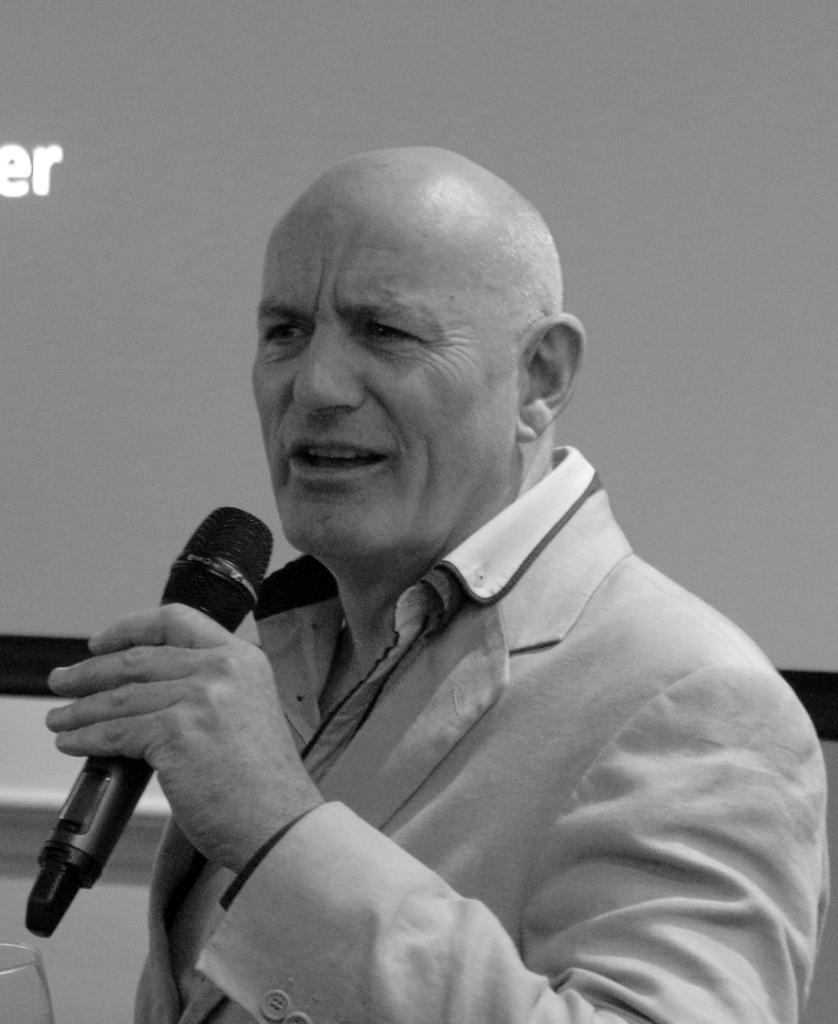What is the person in the image doing? The person is standing and holding a microphone. What might the person be using the microphone for? The person might be using the microphone for speaking or singing. What can be seen in the background of the image? There is a screen in the background of the image. What grade is the person in the image receiving for their performance? There is no indication of a performance or grade in the image, as it only shows a person holding a microphone and a screen in the background. 